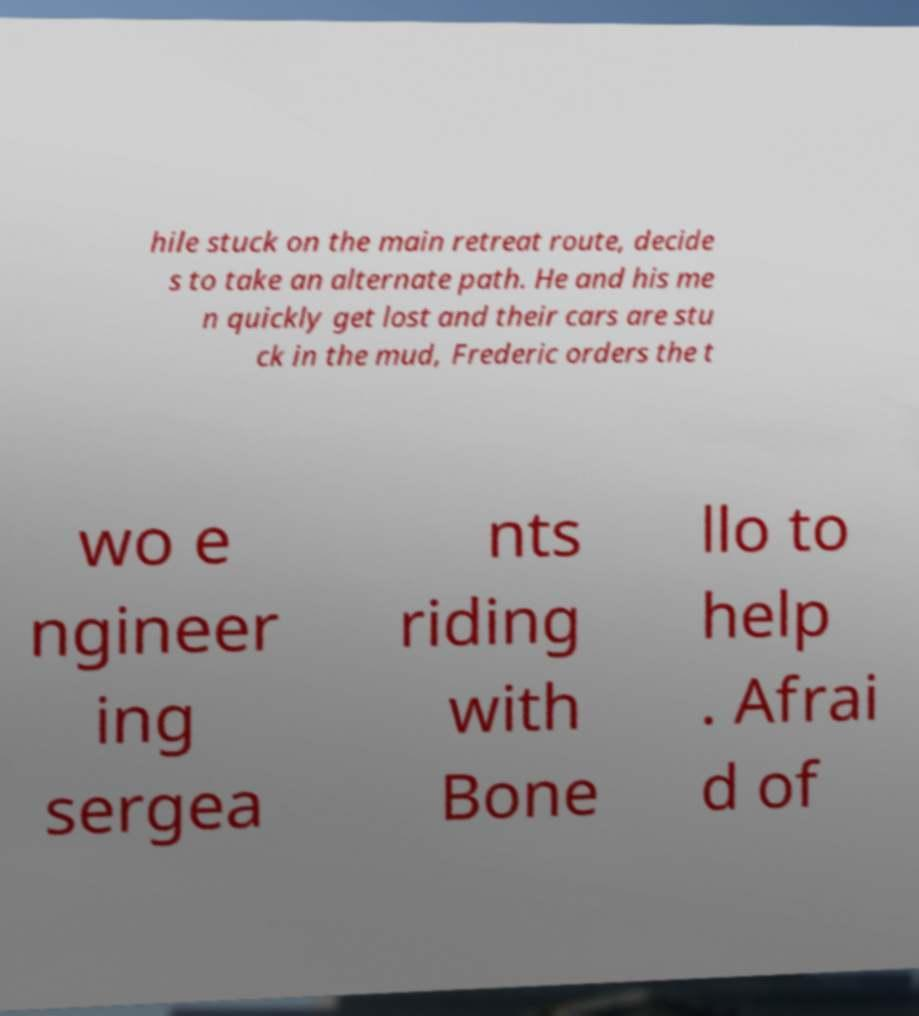Could you extract and type out the text from this image? hile stuck on the main retreat route, decide s to take an alternate path. He and his me n quickly get lost and their cars are stu ck in the mud, Frederic orders the t wo e ngineer ing sergea nts riding with Bone llo to help . Afrai d of 